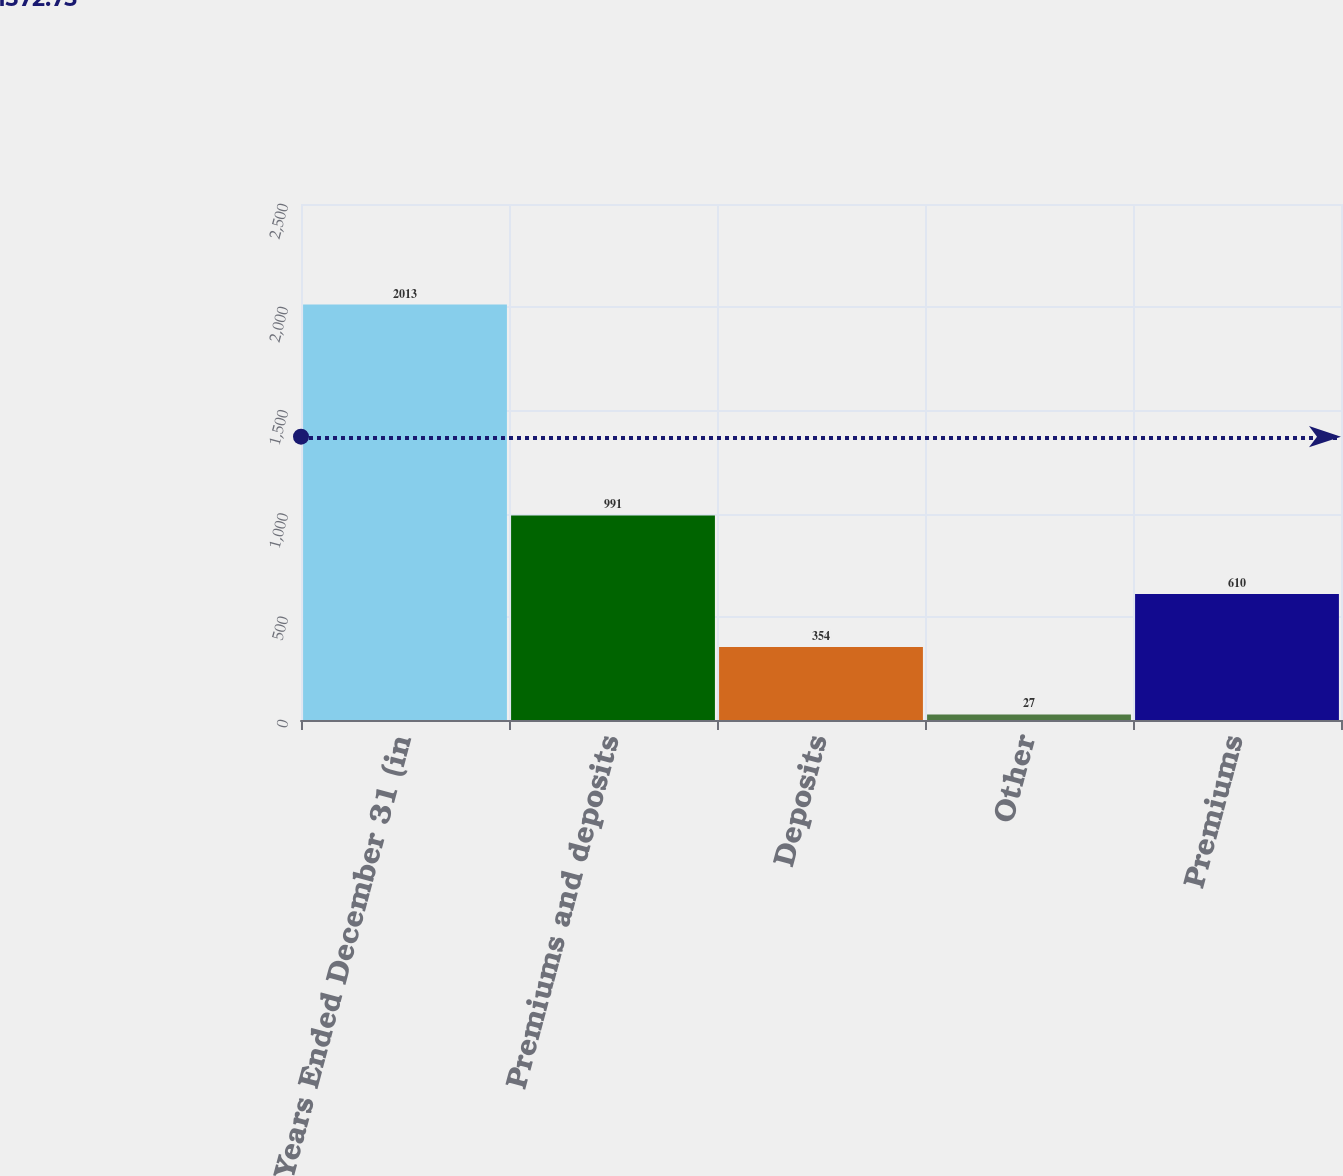<chart> <loc_0><loc_0><loc_500><loc_500><bar_chart><fcel>Years Ended December 31 (in<fcel>Premiums and deposits<fcel>Deposits<fcel>Other<fcel>Premiums<nl><fcel>2013<fcel>991<fcel>354<fcel>27<fcel>610<nl></chart> 